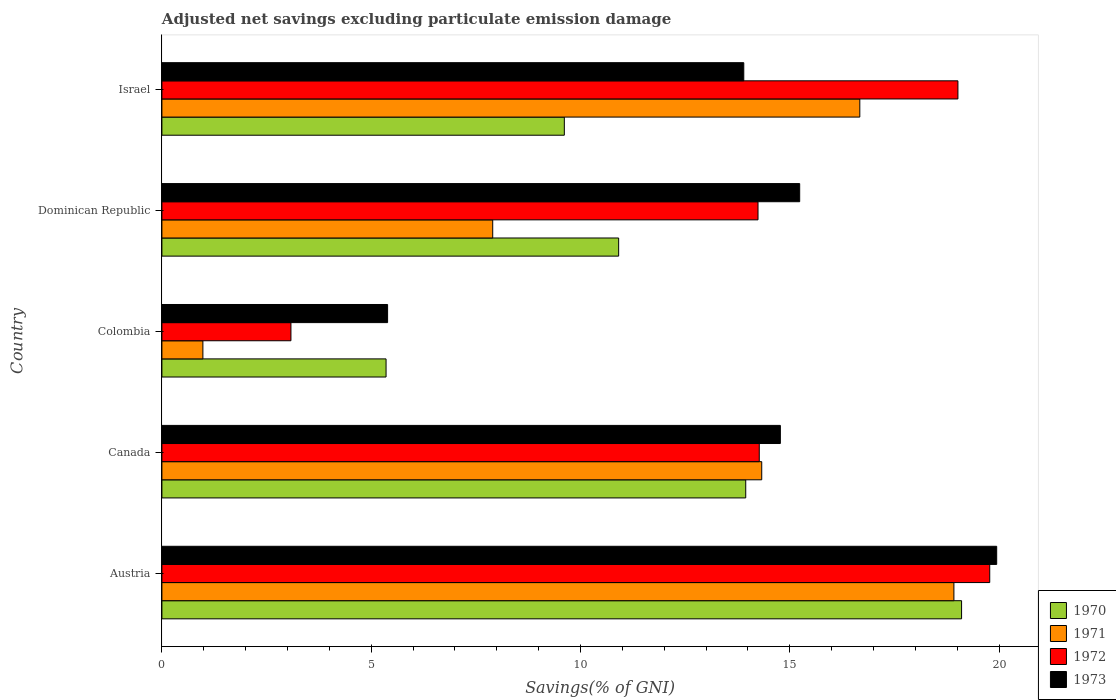How many different coloured bars are there?
Your response must be concise. 4. How many groups of bars are there?
Ensure brevity in your answer.  5. Are the number of bars per tick equal to the number of legend labels?
Ensure brevity in your answer.  Yes. How many bars are there on the 2nd tick from the top?
Make the answer very short. 4. What is the label of the 2nd group of bars from the top?
Make the answer very short. Dominican Republic. What is the adjusted net savings in 1970 in Austria?
Your response must be concise. 19.11. Across all countries, what is the maximum adjusted net savings in 1972?
Offer a terse response. 19.78. Across all countries, what is the minimum adjusted net savings in 1973?
Your response must be concise. 5.39. In which country was the adjusted net savings in 1971 maximum?
Provide a short and direct response. Austria. What is the total adjusted net savings in 1973 in the graph?
Your answer should be very brief. 69.25. What is the difference between the adjusted net savings in 1972 in Dominican Republic and that in Israel?
Keep it short and to the point. -4.78. What is the difference between the adjusted net savings in 1972 in Israel and the adjusted net savings in 1973 in Canada?
Your answer should be compact. 4.24. What is the average adjusted net savings in 1970 per country?
Your answer should be very brief. 11.79. What is the difference between the adjusted net savings in 1970 and adjusted net savings in 1973 in Israel?
Ensure brevity in your answer.  -4.29. What is the ratio of the adjusted net savings in 1972 in Colombia to that in Israel?
Your answer should be compact. 0.16. Is the adjusted net savings in 1971 in Dominican Republic less than that in Israel?
Provide a succinct answer. Yes. What is the difference between the highest and the second highest adjusted net savings in 1970?
Your answer should be very brief. 5.16. What is the difference between the highest and the lowest adjusted net savings in 1971?
Offer a terse response. 17.94. In how many countries, is the adjusted net savings in 1970 greater than the average adjusted net savings in 1970 taken over all countries?
Give a very brief answer. 2. What does the 3rd bar from the top in Dominican Republic represents?
Provide a short and direct response. 1971. Is it the case that in every country, the sum of the adjusted net savings in 1973 and adjusted net savings in 1972 is greater than the adjusted net savings in 1971?
Your answer should be very brief. Yes. How many bars are there?
Your answer should be very brief. 20. Are all the bars in the graph horizontal?
Your answer should be very brief. Yes. Does the graph contain any zero values?
Offer a terse response. No. Does the graph contain grids?
Keep it short and to the point. No. How many legend labels are there?
Your answer should be compact. 4. What is the title of the graph?
Provide a succinct answer. Adjusted net savings excluding particulate emission damage. What is the label or title of the X-axis?
Make the answer very short. Savings(% of GNI). What is the Savings(% of GNI) of 1970 in Austria?
Offer a very short reply. 19.11. What is the Savings(% of GNI) in 1971 in Austria?
Your answer should be very brief. 18.92. What is the Savings(% of GNI) of 1972 in Austria?
Offer a terse response. 19.78. What is the Savings(% of GNI) of 1973 in Austria?
Your response must be concise. 19.94. What is the Savings(% of GNI) in 1970 in Canada?
Your answer should be very brief. 13.95. What is the Savings(% of GNI) in 1971 in Canada?
Your answer should be compact. 14.33. What is the Savings(% of GNI) of 1972 in Canada?
Provide a short and direct response. 14.27. What is the Savings(% of GNI) of 1973 in Canada?
Your response must be concise. 14.78. What is the Savings(% of GNI) of 1970 in Colombia?
Your answer should be compact. 5.36. What is the Savings(% of GNI) in 1971 in Colombia?
Your answer should be compact. 0.98. What is the Savings(% of GNI) in 1972 in Colombia?
Keep it short and to the point. 3.08. What is the Savings(% of GNI) of 1973 in Colombia?
Your answer should be compact. 5.39. What is the Savings(% of GNI) of 1970 in Dominican Republic?
Provide a succinct answer. 10.91. What is the Savings(% of GNI) of 1971 in Dominican Republic?
Offer a terse response. 7.9. What is the Savings(% of GNI) of 1972 in Dominican Republic?
Keep it short and to the point. 14.24. What is the Savings(% of GNI) of 1973 in Dominican Republic?
Offer a very short reply. 15.24. What is the Savings(% of GNI) in 1970 in Israel?
Keep it short and to the point. 9.61. What is the Savings(% of GNI) of 1971 in Israel?
Give a very brief answer. 16.67. What is the Savings(% of GNI) in 1972 in Israel?
Ensure brevity in your answer.  19.02. What is the Savings(% of GNI) in 1973 in Israel?
Provide a succinct answer. 13.9. Across all countries, what is the maximum Savings(% of GNI) of 1970?
Your answer should be compact. 19.11. Across all countries, what is the maximum Savings(% of GNI) in 1971?
Your response must be concise. 18.92. Across all countries, what is the maximum Savings(% of GNI) of 1972?
Offer a terse response. 19.78. Across all countries, what is the maximum Savings(% of GNI) in 1973?
Provide a succinct answer. 19.94. Across all countries, what is the minimum Savings(% of GNI) in 1970?
Your answer should be compact. 5.36. Across all countries, what is the minimum Savings(% of GNI) in 1971?
Give a very brief answer. 0.98. Across all countries, what is the minimum Savings(% of GNI) in 1972?
Keep it short and to the point. 3.08. Across all countries, what is the minimum Savings(% of GNI) in 1973?
Provide a succinct answer. 5.39. What is the total Savings(% of GNI) of 1970 in the graph?
Make the answer very short. 58.94. What is the total Savings(% of GNI) of 1971 in the graph?
Ensure brevity in your answer.  58.81. What is the total Savings(% of GNI) in 1972 in the graph?
Ensure brevity in your answer.  70.39. What is the total Savings(% of GNI) of 1973 in the graph?
Give a very brief answer. 69.25. What is the difference between the Savings(% of GNI) of 1970 in Austria and that in Canada?
Offer a terse response. 5.16. What is the difference between the Savings(% of GNI) in 1971 in Austria and that in Canada?
Provide a short and direct response. 4.59. What is the difference between the Savings(% of GNI) in 1972 in Austria and that in Canada?
Your answer should be very brief. 5.51. What is the difference between the Savings(% of GNI) in 1973 in Austria and that in Canada?
Give a very brief answer. 5.17. What is the difference between the Savings(% of GNI) of 1970 in Austria and that in Colombia?
Provide a succinct answer. 13.75. What is the difference between the Savings(% of GNI) of 1971 in Austria and that in Colombia?
Offer a very short reply. 17.94. What is the difference between the Savings(% of GNI) in 1972 in Austria and that in Colombia?
Your response must be concise. 16.7. What is the difference between the Savings(% of GNI) of 1973 in Austria and that in Colombia?
Keep it short and to the point. 14.55. What is the difference between the Savings(% of GNI) in 1970 in Austria and that in Dominican Republic?
Offer a very short reply. 8.19. What is the difference between the Savings(% of GNI) of 1971 in Austria and that in Dominican Republic?
Ensure brevity in your answer.  11.02. What is the difference between the Savings(% of GNI) of 1972 in Austria and that in Dominican Republic?
Offer a terse response. 5.54. What is the difference between the Savings(% of GNI) of 1973 in Austria and that in Dominican Republic?
Offer a terse response. 4.71. What is the difference between the Savings(% of GNI) in 1970 in Austria and that in Israel?
Your answer should be compact. 9.49. What is the difference between the Savings(% of GNI) in 1971 in Austria and that in Israel?
Offer a very short reply. 2.25. What is the difference between the Savings(% of GNI) of 1972 in Austria and that in Israel?
Keep it short and to the point. 0.76. What is the difference between the Savings(% of GNI) in 1973 in Austria and that in Israel?
Keep it short and to the point. 6.04. What is the difference between the Savings(% of GNI) in 1970 in Canada and that in Colombia?
Your answer should be very brief. 8.59. What is the difference between the Savings(% of GNI) in 1971 in Canada and that in Colombia?
Your response must be concise. 13.35. What is the difference between the Savings(% of GNI) of 1972 in Canada and that in Colombia?
Give a very brief answer. 11.19. What is the difference between the Savings(% of GNI) of 1973 in Canada and that in Colombia?
Provide a succinct answer. 9.38. What is the difference between the Savings(% of GNI) of 1970 in Canada and that in Dominican Republic?
Your answer should be compact. 3.04. What is the difference between the Savings(% of GNI) of 1971 in Canada and that in Dominican Republic?
Your response must be concise. 6.43. What is the difference between the Savings(% of GNI) in 1972 in Canada and that in Dominican Republic?
Your answer should be compact. 0.03. What is the difference between the Savings(% of GNI) of 1973 in Canada and that in Dominican Republic?
Make the answer very short. -0.46. What is the difference between the Savings(% of GNI) in 1970 in Canada and that in Israel?
Ensure brevity in your answer.  4.33. What is the difference between the Savings(% of GNI) of 1971 in Canada and that in Israel?
Provide a short and direct response. -2.34. What is the difference between the Savings(% of GNI) in 1972 in Canada and that in Israel?
Offer a terse response. -4.75. What is the difference between the Savings(% of GNI) of 1973 in Canada and that in Israel?
Give a very brief answer. 0.87. What is the difference between the Savings(% of GNI) of 1970 in Colombia and that in Dominican Republic?
Give a very brief answer. -5.56. What is the difference between the Savings(% of GNI) in 1971 in Colombia and that in Dominican Republic?
Keep it short and to the point. -6.92. What is the difference between the Savings(% of GNI) in 1972 in Colombia and that in Dominican Republic?
Your answer should be very brief. -11.16. What is the difference between the Savings(% of GNI) of 1973 in Colombia and that in Dominican Republic?
Give a very brief answer. -9.85. What is the difference between the Savings(% of GNI) in 1970 in Colombia and that in Israel?
Make the answer very short. -4.26. What is the difference between the Savings(% of GNI) in 1971 in Colombia and that in Israel?
Your response must be concise. -15.7. What is the difference between the Savings(% of GNI) of 1972 in Colombia and that in Israel?
Ensure brevity in your answer.  -15.94. What is the difference between the Savings(% of GNI) of 1973 in Colombia and that in Israel?
Offer a terse response. -8.51. What is the difference between the Savings(% of GNI) of 1970 in Dominican Republic and that in Israel?
Give a very brief answer. 1.3. What is the difference between the Savings(% of GNI) of 1971 in Dominican Republic and that in Israel?
Offer a very short reply. -8.77. What is the difference between the Savings(% of GNI) of 1972 in Dominican Republic and that in Israel?
Your response must be concise. -4.78. What is the difference between the Savings(% of GNI) in 1973 in Dominican Republic and that in Israel?
Provide a short and direct response. 1.34. What is the difference between the Savings(% of GNI) of 1970 in Austria and the Savings(% of GNI) of 1971 in Canada?
Your answer should be compact. 4.77. What is the difference between the Savings(% of GNI) in 1970 in Austria and the Savings(% of GNI) in 1972 in Canada?
Ensure brevity in your answer.  4.83. What is the difference between the Savings(% of GNI) of 1970 in Austria and the Savings(% of GNI) of 1973 in Canada?
Offer a terse response. 4.33. What is the difference between the Savings(% of GNI) in 1971 in Austria and the Savings(% of GNI) in 1972 in Canada?
Ensure brevity in your answer.  4.65. What is the difference between the Savings(% of GNI) in 1971 in Austria and the Savings(% of GNI) in 1973 in Canada?
Provide a short and direct response. 4.15. What is the difference between the Savings(% of GNI) in 1972 in Austria and the Savings(% of GNI) in 1973 in Canada?
Your response must be concise. 5. What is the difference between the Savings(% of GNI) of 1970 in Austria and the Savings(% of GNI) of 1971 in Colombia?
Provide a succinct answer. 18.13. What is the difference between the Savings(% of GNI) of 1970 in Austria and the Savings(% of GNI) of 1972 in Colombia?
Provide a short and direct response. 16.02. What is the difference between the Savings(% of GNI) of 1970 in Austria and the Savings(% of GNI) of 1973 in Colombia?
Ensure brevity in your answer.  13.71. What is the difference between the Savings(% of GNI) of 1971 in Austria and the Savings(% of GNI) of 1972 in Colombia?
Your answer should be compact. 15.84. What is the difference between the Savings(% of GNI) in 1971 in Austria and the Savings(% of GNI) in 1973 in Colombia?
Provide a succinct answer. 13.53. What is the difference between the Savings(% of GNI) in 1972 in Austria and the Savings(% of GNI) in 1973 in Colombia?
Offer a very short reply. 14.39. What is the difference between the Savings(% of GNI) of 1970 in Austria and the Savings(% of GNI) of 1971 in Dominican Republic?
Offer a very short reply. 11.2. What is the difference between the Savings(% of GNI) of 1970 in Austria and the Savings(% of GNI) of 1972 in Dominican Republic?
Provide a short and direct response. 4.86. What is the difference between the Savings(% of GNI) in 1970 in Austria and the Savings(% of GNI) in 1973 in Dominican Republic?
Keep it short and to the point. 3.87. What is the difference between the Savings(% of GNI) in 1971 in Austria and the Savings(% of GNI) in 1972 in Dominican Republic?
Provide a short and direct response. 4.68. What is the difference between the Savings(% of GNI) in 1971 in Austria and the Savings(% of GNI) in 1973 in Dominican Republic?
Offer a terse response. 3.68. What is the difference between the Savings(% of GNI) in 1972 in Austria and the Savings(% of GNI) in 1973 in Dominican Republic?
Make the answer very short. 4.54. What is the difference between the Savings(% of GNI) in 1970 in Austria and the Savings(% of GNI) in 1971 in Israel?
Keep it short and to the point. 2.43. What is the difference between the Savings(% of GNI) in 1970 in Austria and the Savings(% of GNI) in 1972 in Israel?
Your answer should be compact. 0.09. What is the difference between the Savings(% of GNI) in 1970 in Austria and the Savings(% of GNI) in 1973 in Israel?
Provide a succinct answer. 5.2. What is the difference between the Savings(% of GNI) in 1971 in Austria and the Savings(% of GNI) in 1972 in Israel?
Your response must be concise. -0.1. What is the difference between the Savings(% of GNI) in 1971 in Austria and the Savings(% of GNI) in 1973 in Israel?
Make the answer very short. 5.02. What is the difference between the Savings(% of GNI) of 1972 in Austria and the Savings(% of GNI) of 1973 in Israel?
Ensure brevity in your answer.  5.88. What is the difference between the Savings(% of GNI) in 1970 in Canada and the Savings(% of GNI) in 1971 in Colombia?
Give a very brief answer. 12.97. What is the difference between the Savings(% of GNI) in 1970 in Canada and the Savings(% of GNI) in 1972 in Colombia?
Your answer should be very brief. 10.87. What is the difference between the Savings(% of GNI) in 1970 in Canada and the Savings(% of GNI) in 1973 in Colombia?
Keep it short and to the point. 8.56. What is the difference between the Savings(% of GNI) of 1971 in Canada and the Savings(% of GNI) of 1972 in Colombia?
Your answer should be very brief. 11.25. What is the difference between the Savings(% of GNI) in 1971 in Canada and the Savings(% of GNI) in 1973 in Colombia?
Your answer should be compact. 8.94. What is the difference between the Savings(% of GNI) of 1972 in Canada and the Savings(% of GNI) of 1973 in Colombia?
Offer a very short reply. 8.88. What is the difference between the Savings(% of GNI) of 1970 in Canada and the Savings(% of GNI) of 1971 in Dominican Republic?
Keep it short and to the point. 6.05. What is the difference between the Savings(% of GNI) of 1970 in Canada and the Savings(% of GNI) of 1972 in Dominican Republic?
Offer a terse response. -0.29. What is the difference between the Savings(% of GNI) of 1970 in Canada and the Savings(% of GNI) of 1973 in Dominican Republic?
Your response must be concise. -1.29. What is the difference between the Savings(% of GNI) of 1971 in Canada and the Savings(% of GNI) of 1972 in Dominican Republic?
Provide a succinct answer. 0.09. What is the difference between the Savings(% of GNI) of 1971 in Canada and the Savings(% of GNI) of 1973 in Dominican Republic?
Give a very brief answer. -0.91. What is the difference between the Savings(% of GNI) in 1972 in Canada and the Savings(% of GNI) in 1973 in Dominican Republic?
Your response must be concise. -0.97. What is the difference between the Savings(% of GNI) of 1970 in Canada and the Savings(% of GNI) of 1971 in Israel?
Ensure brevity in your answer.  -2.73. What is the difference between the Savings(% of GNI) in 1970 in Canada and the Savings(% of GNI) in 1972 in Israel?
Your answer should be compact. -5.07. What is the difference between the Savings(% of GNI) of 1970 in Canada and the Savings(% of GNI) of 1973 in Israel?
Make the answer very short. 0.05. What is the difference between the Savings(% of GNI) of 1971 in Canada and the Savings(% of GNI) of 1972 in Israel?
Keep it short and to the point. -4.69. What is the difference between the Savings(% of GNI) in 1971 in Canada and the Savings(% of GNI) in 1973 in Israel?
Your response must be concise. 0.43. What is the difference between the Savings(% of GNI) in 1972 in Canada and the Savings(% of GNI) in 1973 in Israel?
Your response must be concise. 0.37. What is the difference between the Savings(% of GNI) in 1970 in Colombia and the Savings(% of GNI) in 1971 in Dominican Republic?
Your answer should be compact. -2.55. What is the difference between the Savings(% of GNI) of 1970 in Colombia and the Savings(% of GNI) of 1972 in Dominican Republic?
Your answer should be compact. -8.89. What is the difference between the Savings(% of GNI) in 1970 in Colombia and the Savings(% of GNI) in 1973 in Dominican Republic?
Ensure brevity in your answer.  -9.88. What is the difference between the Savings(% of GNI) in 1971 in Colombia and the Savings(% of GNI) in 1972 in Dominican Republic?
Offer a very short reply. -13.26. What is the difference between the Savings(% of GNI) in 1971 in Colombia and the Savings(% of GNI) in 1973 in Dominican Republic?
Your response must be concise. -14.26. What is the difference between the Savings(% of GNI) in 1972 in Colombia and the Savings(% of GNI) in 1973 in Dominican Republic?
Offer a very short reply. -12.15. What is the difference between the Savings(% of GNI) of 1970 in Colombia and the Savings(% of GNI) of 1971 in Israel?
Your answer should be very brief. -11.32. What is the difference between the Savings(% of GNI) of 1970 in Colombia and the Savings(% of GNI) of 1972 in Israel?
Provide a short and direct response. -13.66. What is the difference between the Savings(% of GNI) of 1970 in Colombia and the Savings(% of GNI) of 1973 in Israel?
Your answer should be very brief. -8.55. What is the difference between the Savings(% of GNI) of 1971 in Colombia and the Savings(% of GNI) of 1972 in Israel?
Ensure brevity in your answer.  -18.04. What is the difference between the Savings(% of GNI) in 1971 in Colombia and the Savings(% of GNI) in 1973 in Israel?
Offer a terse response. -12.92. What is the difference between the Savings(% of GNI) of 1972 in Colombia and the Savings(% of GNI) of 1973 in Israel?
Provide a short and direct response. -10.82. What is the difference between the Savings(% of GNI) of 1970 in Dominican Republic and the Savings(% of GNI) of 1971 in Israel?
Keep it short and to the point. -5.76. What is the difference between the Savings(% of GNI) in 1970 in Dominican Republic and the Savings(% of GNI) in 1972 in Israel?
Give a very brief answer. -8.11. What is the difference between the Savings(% of GNI) of 1970 in Dominican Republic and the Savings(% of GNI) of 1973 in Israel?
Your answer should be compact. -2.99. What is the difference between the Savings(% of GNI) in 1971 in Dominican Republic and the Savings(% of GNI) in 1972 in Israel?
Give a very brief answer. -11.11. What is the difference between the Savings(% of GNI) of 1971 in Dominican Republic and the Savings(% of GNI) of 1973 in Israel?
Ensure brevity in your answer.  -6. What is the difference between the Savings(% of GNI) of 1972 in Dominican Republic and the Savings(% of GNI) of 1973 in Israel?
Offer a terse response. 0.34. What is the average Savings(% of GNI) of 1970 per country?
Keep it short and to the point. 11.79. What is the average Savings(% of GNI) in 1971 per country?
Give a very brief answer. 11.76. What is the average Savings(% of GNI) of 1972 per country?
Give a very brief answer. 14.08. What is the average Savings(% of GNI) of 1973 per country?
Make the answer very short. 13.85. What is the difference between the Savings(% of GNI) in 1970 and Savings(% of GNI) in 1971 in Austria?
Ensure brevity in your answer.  0.18. What is the difference between the Savings(% of GNI) of 1970 and Savings(% of GNI) of 1972 in Austria?
Your answer should be compact. -0.67. What is the difference between the Savings(% of GNI) in 1970 and Savings(% of GNI) in 1973 in Austria?
Make the answer very short. -0.84. What is the difference between the Savings(% of GNI) in 1971 and Savings(% of GNI) in 1972 in Austria?
Your response must be concise. -0.86. What is the difference between the Savings(% of GNI) of 1971 and Savings(% of GNI) of 1973 in Austria?
Ensure brevity in your answer.  -1.02. What is the difference between the Savings(% of GNI) of 1972 and Savings(% of GNI) of 1973 in Austria?
Provide a succinct answer. -0.17. What is the difference between the Savings(% of GNI) in 1970 and Savings(% of GNI) in 1971 in Canada?
Keep it short and to the point. -0.38. What is the difference between the Savings(% of GNI) of 1970 and Savings(% of GNI) of 1972 in Canada?
Offer a very short reply. -0.32. What is the difference between the Savings(% of GNI) of 1970 and Savings(% of GNI) of 1973 in Canada?
Offer a very short reply. -0.83. What is the difference between the Savings(% of GNI) in 1971 and Savings(% of GNI) in 1972 in Canada?
Your answer should be compact. 0.06. What is the difference between the Savings(% of GNI) of 1971 and Savings(% of GNI) of 1973 in Canada?
Your response must be concise. -0.45. What is the difference between the Savings(% of GNI) in 1972 and Savings(% of GNI) in 1973 in Canada?
Make the answer very short. -0.5. What is the difference between the Savings(% of GNI) of 1970 and Savings(% of GNI) of 1971 in Colombia?
Keep it short and to the point. 4.38. What is the difference between the Savings(% of GNI) in 1970 and Savings(% of GNI) in 1972 in Colombia?
Make the answer very short. 2.27. What is the difference between the Savings(% of GNI) of 1970 and Savings(% of GNI) of 1973 in Colombia?
Your answer should be very brief. -0.04. What is the difference between the Savings(% of GNI) in 1971 and Savings(% of GNI) in 1972 in Colombia?
Ensure brevity in your answer.  -2.1. What is the difference between the Savings(% of GNI) of 1971 and Savings(% of GNI) of 1973 in Colombia?
Keep it short and to the point. -4.41. What is the difference between the Savings(% of GNI) of 1972 and Savings(% of GNI) of 1973 in Colombia?
Offer a very short reply. -2.31. What is the difference between the Savings(% of GNI) in 1970 and Savings(% of GNI) in 1971 in Dominican Republic?
Offer a terse response. 3.01. What is the difference between the Savings(% of GNI) in 1970 and Savings(% of GNI) in 1972 in Dominican Republic?
Offer a very short reply. -3.33. What is the difference between the Savings(% of GNI) of 1970 and Savings(% of GNI) of 1973 in Dominican Republic?
Keep it short and to the point. -4.33. What is the difference between the Savings(% of GNI) in 1971 and Savings(% of GNI) in 1972 in Dominican Republic?
Keep it short and to the point. -6.34. What is the difference between the Savings(% of GNI) of 1971 and Savings(% of GNI) of 1973 in Dominican Republic?
Offer a terse response. -7.33. What is the difference between the Savings(% of GNI) of 1972 and Savings(% of GNI) of 1973 in Dominican Republic?
Make the answer very short. -1. What is the difference between the Savings(% of GNI) in 1970 and Savings(% of GNI) in 1971 in Israel?
Ensure brevity in your answer.  -7.06. What is the difference between the Savings(% of GNI) in 1970 and Savings(% of GNI) in 1972 in Israel?
Keep it short and to the point. -9.4. What is the difference between the Savings(% of GNI) of 1970 and Savings(% of GNI) of 1973 in Israel?
Your response must be concise. -4.29. What is the difference between the Savings(% of GNI) in 1971 and Savings(% of GNI) in 1972 in Israel?
Your answer should be compact. -2.34. What is the difference between the Savings(% of GNI) of 1971 and Savings(% of GNI) of 1973 in Israel?
Ensure brevity in your answer.  2.77. What is the difference between the Savings(% of GNI) in 1972 and Savings(% of GNI) in 1973 in Israel?
Keep it short and to the point. 5.12. What is the ratio of the Savings(% of GNI) of 1970 in Austria to that in Canada?
Keep it short and to the point. 1.37. What is the ratio of the Savings(% of GNI) of 1971 in Austria to that in Canada?
Offer a terse response. 1.32. What is the ratio of the Savings(% of GNI) of 1972 in Austria to that in Canada?
Your answer should be compact. 1.39. What is the ratio of the Savings(% of GNI) in 1973 in Austria to that in Canada?
Provide a short and direct response. 1.35. What is the ratio of the Savings(% of GNI) in 1970 in Austria to that in Colombia?
Provide a succinct answer. 3.57. What is the ratio of the Savings(% of GNI) in 1971 in Austria to that in Colombia?
Your answer should be very brief. 19.32. What is the ratio of the Savings(% of GNI) of 1972 in Austria to that in Colombia?
Offer a very short reply. 6.42. What is the ratio of the Savings(% of GNI) in 1973 in Austria to that in Colombia?
Keep it short and to the point. 3.7. What is the ratio of the Savings(% of GNI) of 1970 in Austria to that in Dominican Republic?
Provide a short and direct response. 1.75. What is the ratio of the Savings(% of GNI) of 1971 in Austria to that in Dominican Republic?
Give a very brief answer. 2.39. What is the ratio of the Savings(% of GNI) of 1972 in Austria to that in Dominican Republic?
Offer a terse response. 1.39. What is the ratio of the Savings(% of GNI) in 1973 in Austria to that in Dominican Republic?
Offer a terse response. 1.31. What is the ratio of the Savings(% of GNI) of 1970 in Austria to that in Israel?
Make the answer very short. 1.99. What is the ratio of the Savings(% of GNI) in 1971 in Austria to that in Israel?
Provide a short and direct response. 1.13. What is the ratio of the Savings(% of GNI) in 1973 in Austria to that in Israel?
Your response must be concise. 1.43. What is the ratio of the Savings(% of GNI) of 1970 in Canada to that in Colombia?
Your answer should be compact. 2.6. What is the ratio of the Savings(% of GNI) in 1971 in Canada to that in Colombia?
Give a very brief answer. 14.64. What is the ratio of the Savings(% of GNI) of 1972 in Canada to that in Colombia?
Provide a short and direct response. 4.63. What is the ratio of the Savings(% of GNI) of 1973 in Canada to that in Colombia?
Keep it short and to the point. 2.74. What is the ratio of the Savings(% of GNI) of 1970 in Canada to that in Dominican Republic?
Offer a very short reply. 1.28. What is the ratio of the Savings(% of GNI) of 1971 in Canada to that in Dominican Republic?
Provide a short and direct response. 1.81. What is the ratio of the Savings(% of GNI) in 1972 in Canada to that in Dominican Republic?
Your response must be concise. 1. What is the ratio of the Savings(% of GNI) of 1973 in Canada to that in Dominican Republic?
Provide a succinct answer. 0.97. What is the ratio of the Savings(% of GNI) in 1970 in Canada to that in Israel?
Keep it short and to the point. 1.45. What is the ratio of the Savings(% of GNI) in 1971 in Canada to that in Israel?
Provide a succinct answer. 0.86. What is the ratio of the Savings(% of GNI) in 1972 in Canada to that in Israel?
Your response must be concise. 0.75. What is the ratio of the Savings(% of GNI) of 1973 in Canada to that in Israel?
Offer a terse response. 1.06. What is the ratio of the Savings(% of GNI) in 1970 in Colombia to that in Dominican Republic?
Give a very brief answer. 0.49. What is the ratio of the Savings(% of GNI) of 1971 in Colombia to that in Dominican Republic?
Make the answer very short. 0.12. What is the ratio of the Savings(% of GNI) of 1972 in Colombia to that in Dominican Republic?
Offer a very short reply. 0.22. What is the ratio of the Savings(% of GNI) of 1973 in Colombia to that in Dominican Republic?
Provide a short and direct response. 0.35. What is the ratio of the Savings(% of GNI) of 1970 in Colombia to that in Israel?
Offer a very short reply. 0.56. What is the ratio of the Savings(% of GNI) in 1971 in Colombia to that in Israel?
Provide a succinct answer. 0.06. What is the ratio of the Savings(% of GNI) in 1972 in Colombia to that in Israel?
Provide a short and direct response. 0.16. What is the ratio of the Savings(% of GNI) in 1973 in Colombia to that in Israel?
Give a very brief answer. 0.39. What is the ratio of the Savings(% of GNI) in 1970 in Dominican Republic to that in Israel?
Offer a very short reply. 1.14. What is the ratio of the Savings(% of GNI) in 1971 in Dominican Republic to that in Israel?
Your answer should be very brief. 0.47. What is the ratio of the Savings(% of GNI) of 1972 in Dominican Republic to that in Israel?
Your answer should be very brief. 0.75. What is the ratio of the Savings(% of GNI) in 1973 in Dominican Republic to that in Israel?
Make the answer very short. 1.1. What is the difference between the highest and the second highest Savings(% of GNI) in 1970?
Your answer should be compact. 5.16. What is the difference between the highest and the second highest Savings(% of GNI) in 1971?
Your response must be concise. 2.25. What is the difference between the highest and the second highest Savings(% of GNI) of 1972?
Provide a succinct answer. 0.76. What is the difference between the highest and the second highest Savings(% of GNI) of 1973?
Provide a short and direct response. 4.71. What is the difference between the highest and the lowest Savings(% of GNI) in 1970?
Provide a succinct answer. 13.75. What is the difference between the highest and the lowest Savings(% of GNI) in 1971?
Keep it short and to the point. 17.94. What is the difference between the highest and the lowest Savings(% of GNI) in 1972?
Your response must be concise. 16.7. What is the difference between the highest and the lowest Savings(% of GNI) in 1973?
Keep it short and to the point. 14.55. 